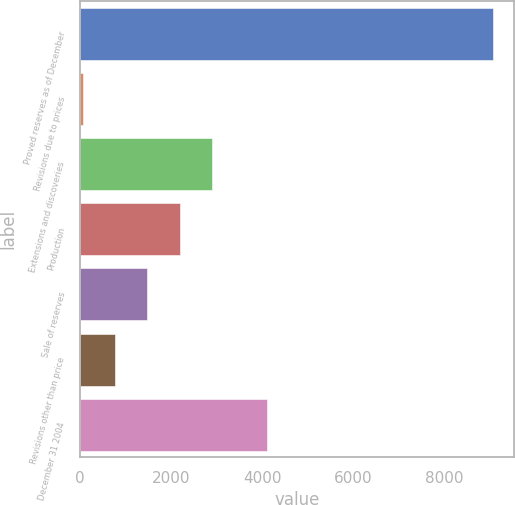Convert chart. <chart><loc_0><loc_0><loc_500><loc_500><bar_chart><fcel>Proved reserves as of December<fcel>Revisions due to prices<fcel>Extensions and discoveries<fcel>Production<fcel>Sale of reserves<fcel>Revisions other than price<fcel>December 31 2004<nl><fcel>9064.5<fcel>58<fcel>2892<fcel>2183.5<fcel>1475<fcel>766.5<fcel>4105<nl></chart> 